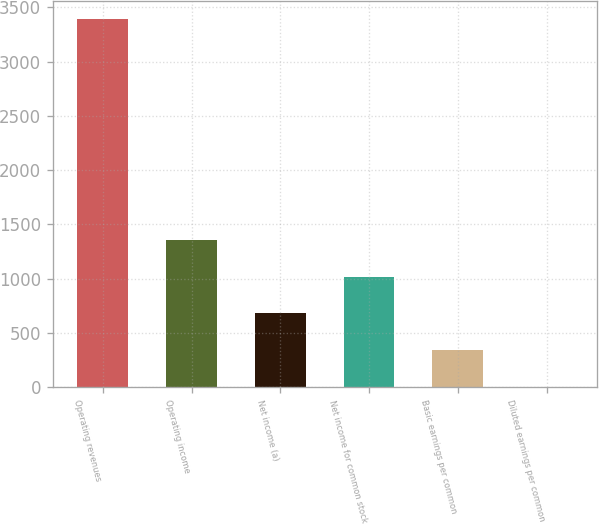Convert chart. <chart><loc_0><loc_0><loc_500><loc_500><bar_chart><fcel>Operating revenues<fcel>Operating income<fcel>Net income (a)<fcel>Net income for common stock<fcel>Basic earnings per common<fcel>Diluted earnings per common<nl><fcel>3390<fcel>1356.88<fcel>679.18<fcel>1018.03<fcel>340.33<fcel>1.48<nl></chart> 